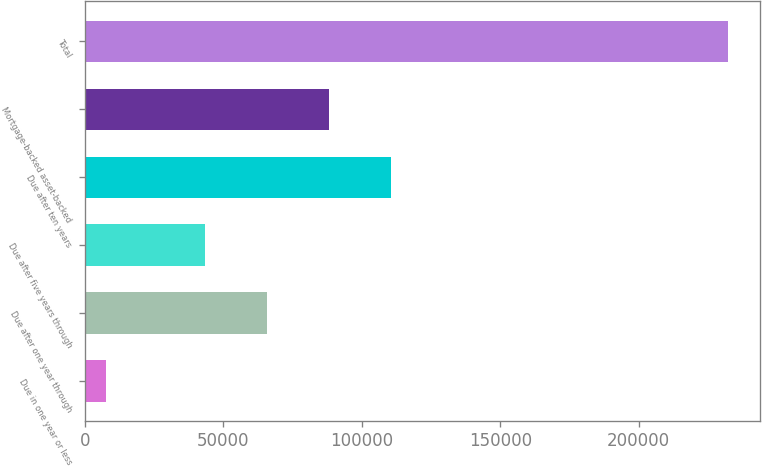Convert chart. <chart><loc_0><loc_0><loc_500><loc_500><bar_chart><fcel>Due in one year or less<fcel>Due after one year through<fcel>Due after five years through<fcel>Due after ten years<fcel>Mortgage-backed asset-backed<fcel>Total<nl><fcel>7796<fcel>65752.5<fcel>43308<fcel>110642<fcel>88197<fcel>232241<nl></chart> 